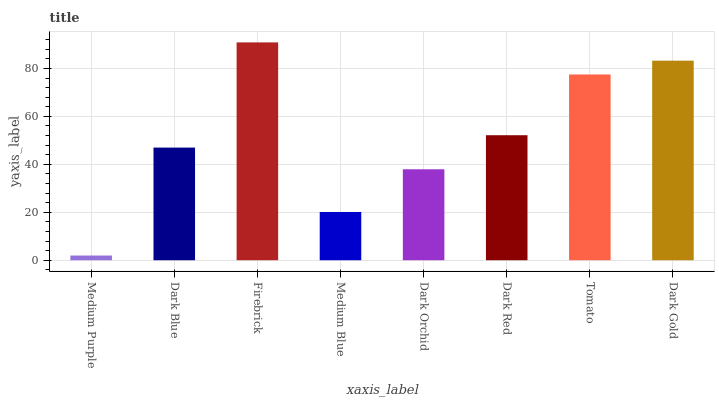Is Medium Purple the minimum?
Answer yes or no. Yes. Is Firebrick the maximum?
Answer yes or no. Yes. Is Dark Blue the minimum?
Answer yes or no. No. Is Dark Blue the maximum?
Answer yes or no. No. Is Dark Blue greater than Medium Purple?
Answer yes or no. Yes. Is Medium Purple less than Dark Blue?
Answer yes or no. Yes. Is Medium Purple greater than Dark Blue?
Answer yes or no. No. Is Dark Blue less than Medium Purple?
Answer yes or no. No. Is Dark Red the high median?
Answer yes or no. Yes. Is Dark Blue the low median?
Answer yes or no. Yes. Is Medium Purple the high median?
Answer yes or no. No. Is Medium Blue the low median?
Answer yes or no. No. 